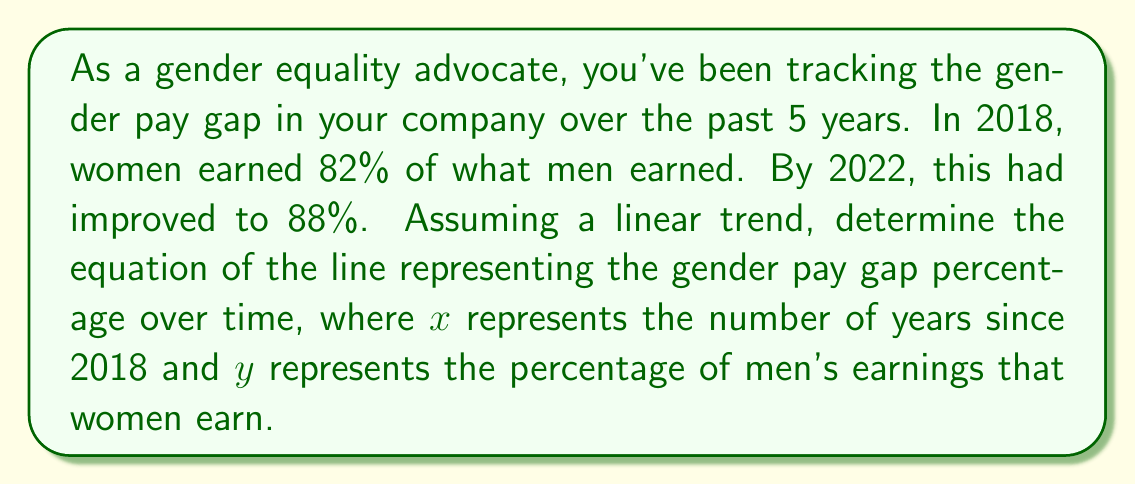Teach me how to tackle this problem. To solve this problem, we'll use the point-slope form of a line equation: $y - y_1 = m(x - x_1)$

1. Identify two points:
   $(x_1, y_1) = (0, 82)$ for 2018
   $(x_2, y_2) = (4, 88)$ for 2022

2. Calculate the slope:
   $m = \frac{y_2 - y_1}{x_2 - x_1} = \frac{88 - 82}{4 - 0} = \frac{6}{4} = 1.5$

3. Use the point-slope form with $(x_1, y_1) = (0, 82)$:
   $y - 82 = 1.5(x - 0)$

4. Simplify:
   $y - 82 = 1.5x$

5. Solve for $y$:
   $y = 1.5x + 82$

This equation represents the gender pay gap percentage over time, where $x$ is the number of years since 2018 and $y$ is the percentage of men's earnings that women earn.
Answer: $y = 1.5x + 82$ 